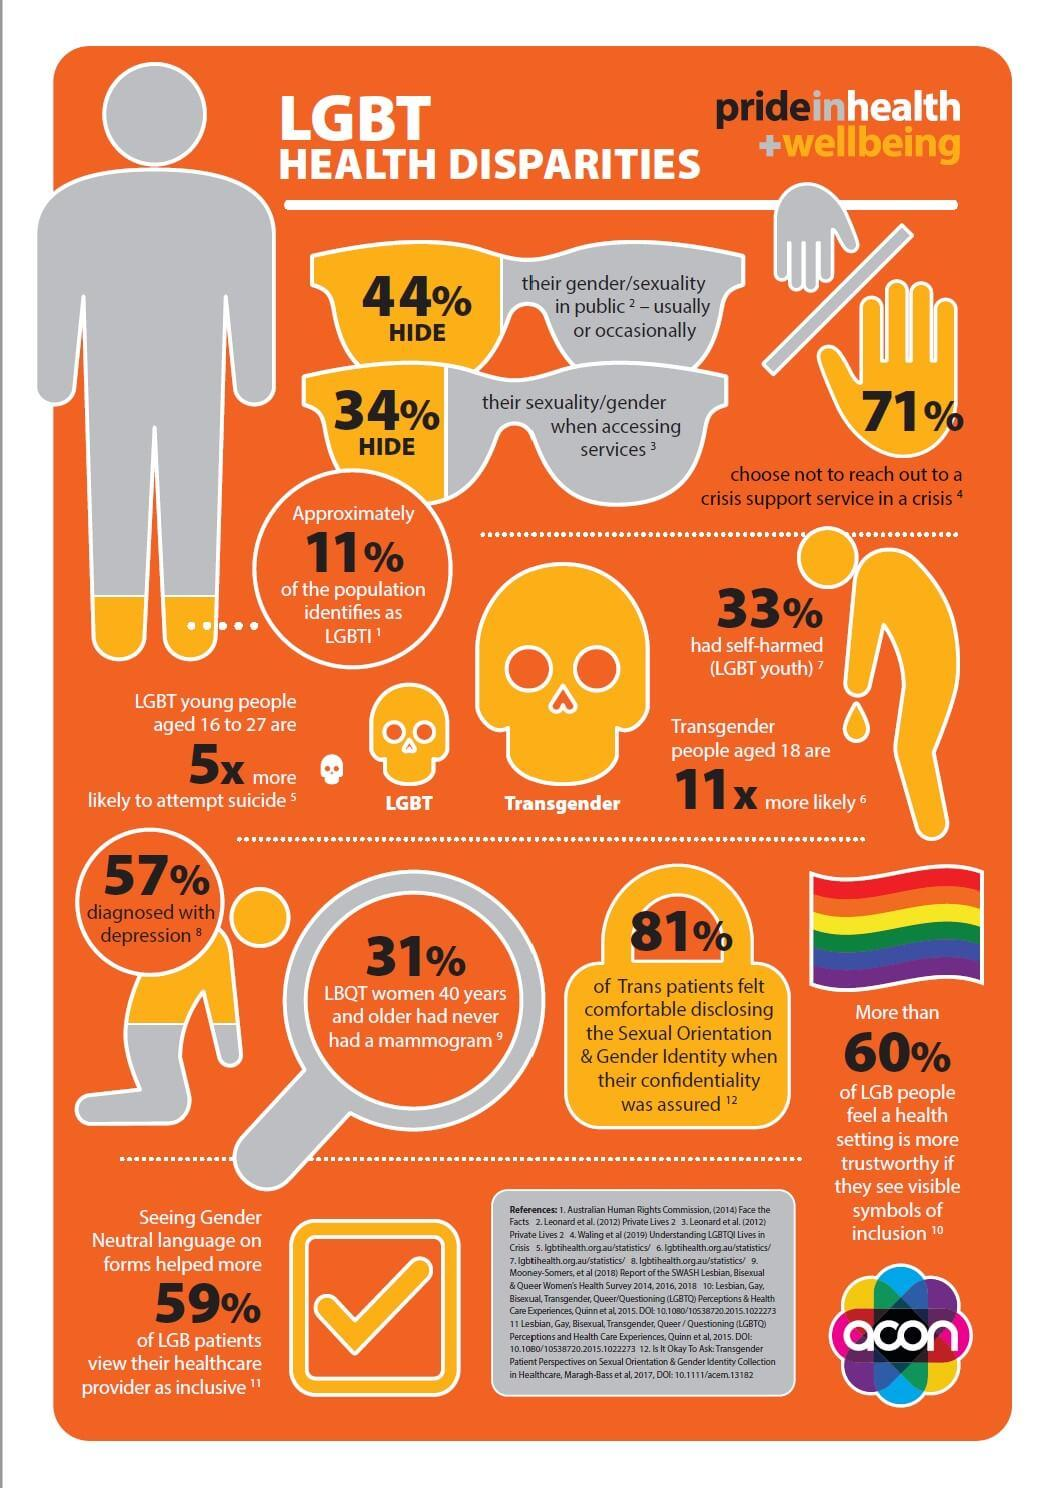Indicate a few pertinent items in this graphic. According to recent studies, approximately 11% of the population identifies as LGBTI. According to a recent study, 71% of people choose not to seek support from a crisis support service during a crisis. According to a recent study, approximately 57% of individuals diagnosed with depression. According to the study, 33% of LGBT youth had self-harmed. 